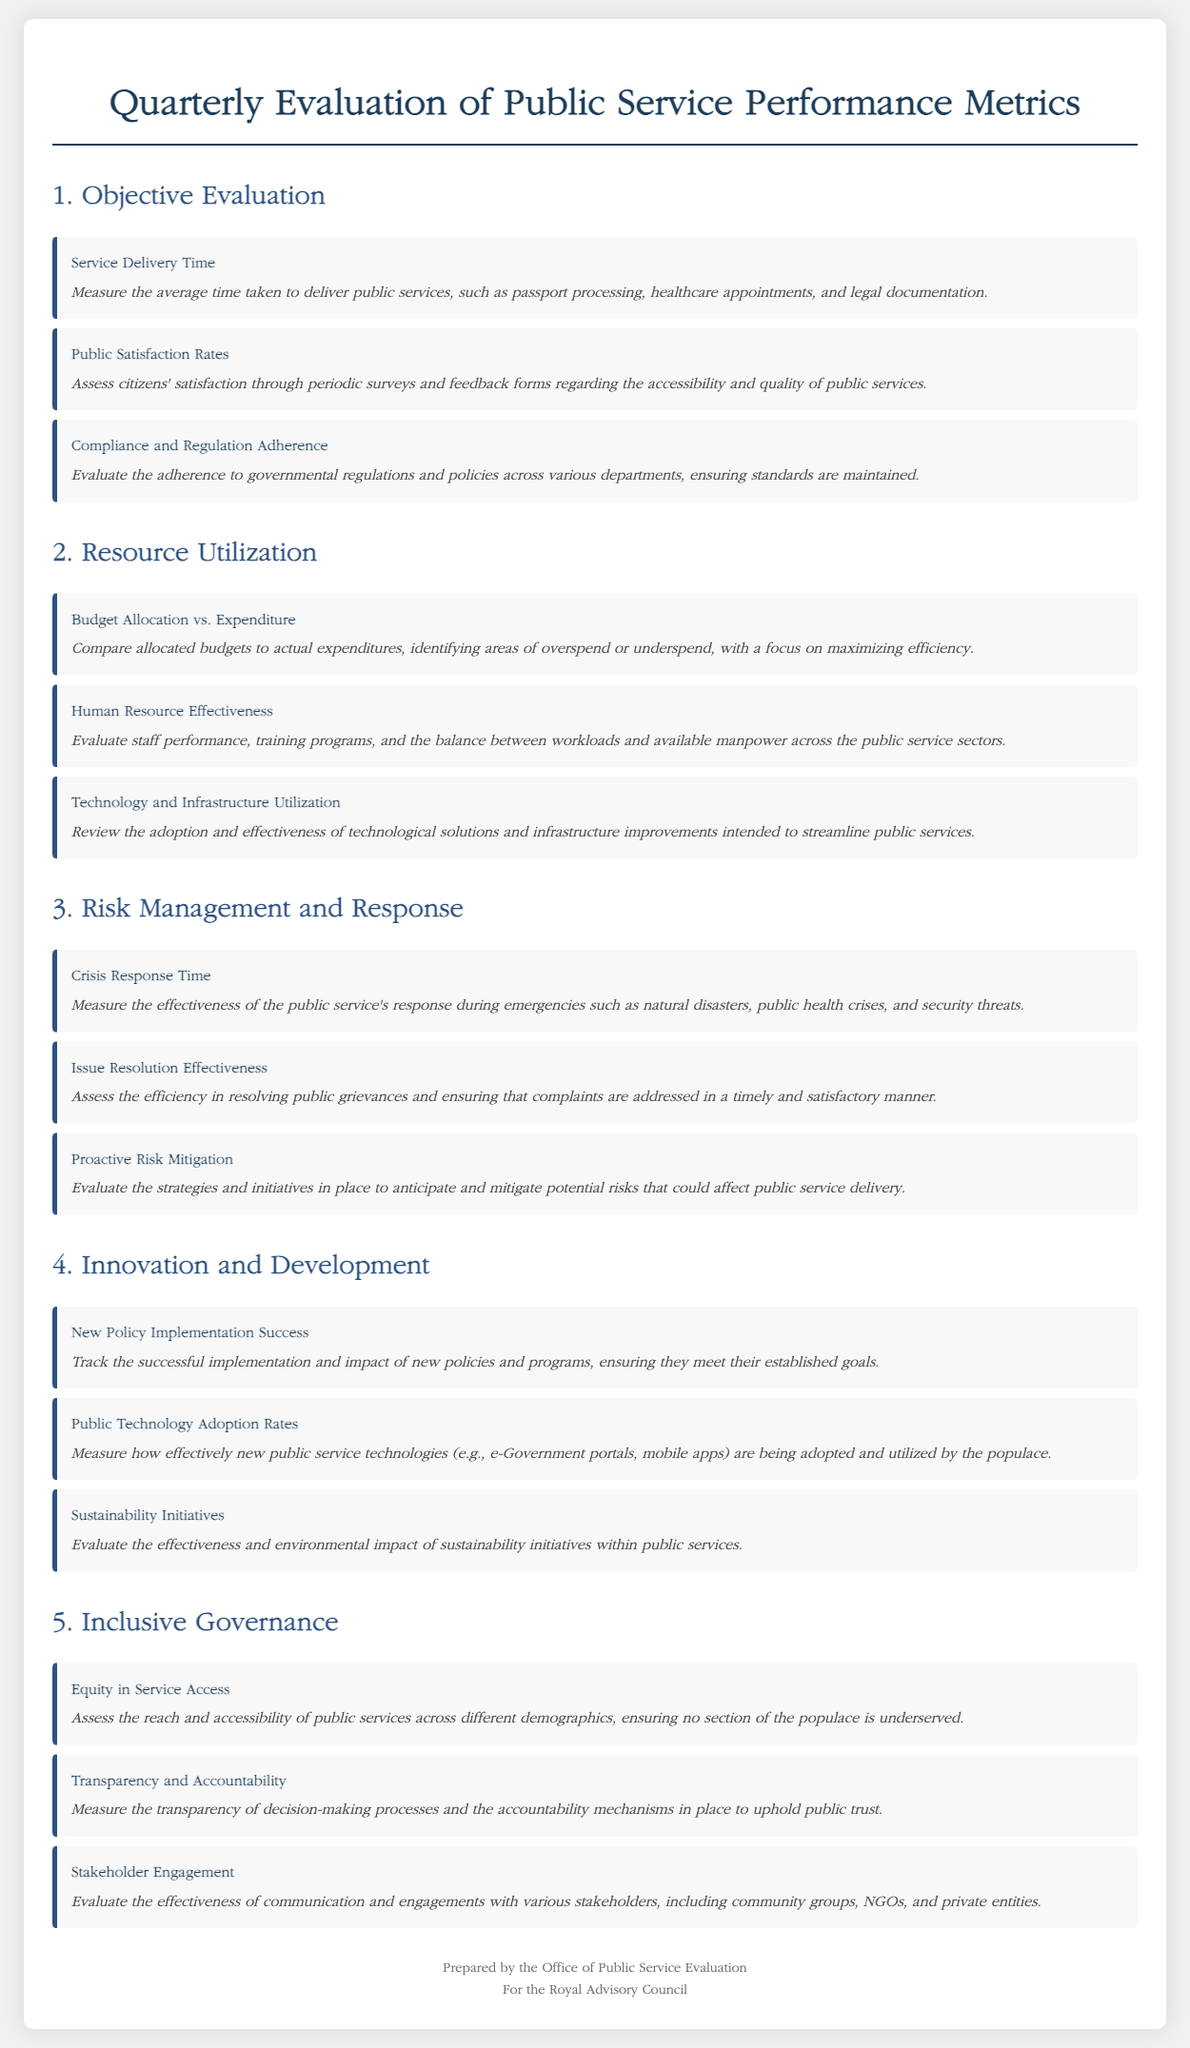What is the first metric listed under Objective Evaluation? The first metric is explicitly stated in the document as "Service Delivery Time."
Answer: Service Delivery Time What is assessed under Public Satisfaction Rates? The document indicates that this metric assesses citizens' satisfaction through periodic surveys and feedback forms.
Answer: Citizens' satisfaction What is compared in the Resource Utilization section regarding financials? The document specifies that it compares "Budget Allocation vs. Expenditure."
Answer: Budget Allocation vs. Expenditure How are public grievances measured in Risk Management and Response? The effectiveness in resolving public grievances is measured through the metric titled "Issue Resolution Effectiveness."
Answer: Issue Resolution Effectiveness What happens during the assessment of New Policy Implementation Success? The document mentions tracking the successful implementation and impact of new policies and programs.
Answer: Track successful implementation What demographic aspect is covered under Inclusive Governance? The metric "Equity in Service Access" evaluates accessibility of public services across different demographics.
Answer: Equity in Service Access What department is responsible for preparing the document according to the royal seal? The document states that it is prepared by the "Office of Public Service Evaluation."
Answer: Office of Public Service Evaluation What is the primary focus of Sustainability Initiatives? The effectiveness and environmental impact of sustainability initiatives within public services is the focus.
Answer: Effectiveness and environmental impact What does the document suggest about technology adoption? The metric "Public Technology Adoption Rates" measures how effectively new public service technologies are adopted.
Answer: Public Technology Adoption Rates 